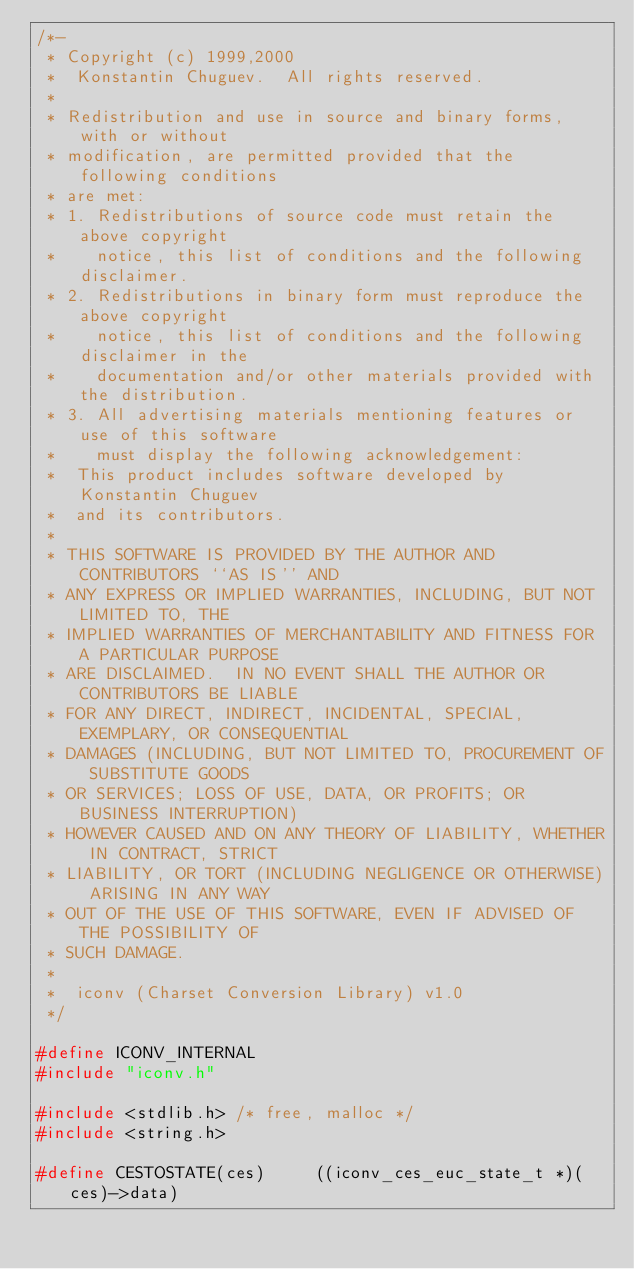<code> <loc_0><loc_0><loc_500><loc_500><_C_>/*-
 * Copyright (c) 1999,2000
 *	Konstantin Chuguev.  All rights reserved.
 *
 * Redistribution and use in source and binary forms, with or without
 * modification, are permitted provided that the following conditions
 * are met:
 * 1. Redistributions of source code must retain the above copyright
 *    notice, this list of conditions and the following disclaimer.
 * 2. Redistributions in binary form must reproduce the above copyright
 *    notice, this list of conditions and the following disclaimer in the
 *    documentation and/or other materials provided with the distribution.
 * 3. All advertising materials mentioning features or use of this software
 *    must display the following acknowledgement:
 *	This product includes software developed by Konstantin Chuguev
 *	and its contributors.
 *
 * THIS SOFTWARE IS PROVIDED BY THE AUTHOR AND CONTRIBUTORS ``AS IS'' AND
 * ANY EXPRESS OR IMPLIED WARRANTIES, INCLUDING, BUT NOT LIMITED TO, THE
 * IMPLIED WARRANTIES OF MERCHANTABILITY AND FITNESS FOR A PARTICULAR PURPOSE
 * ARE DISCLAIMED.  IN NO EVENT SHALL THE AUTHOR OR CONTRIBUTORS BE LIABLE
 * FOR ANY DIRECT, INDIRECT, INCIDENTAL, SPECIAL, EXEMPLARY, OR CONSEQUENTIAL
 * DAMAGES (INCLUDING, BUT NOT LIMITED TO, PROCUREMENT OF SUBSTITUTE GOODS
 * OR SERVICES; LOSS OF USE, DATA, OR PROFITS; OR BUSINESS INTERRUPTION)
 * HOWEVER CAUSED AND ON ANY THEORY OF LIABILITY, WHETHER IN CONTRACT, STRICT
 * LIABILITY, OR TORT (INCLUDING NEGLIGENCE OR OTHERWISE) ARISING IN ANY WAY
 * OUT OF THE USE OF THIS SOFTWARE, EVEN IF ADVISED OF THE POSSIBILITY OF
 * SUCH DAMAGE.
 *
 *	iconv (Charset Conversion Library) v1.0
 */

#define ICONV_INTERNAL
#include "iconv.h"

#include <stdlib.h>	/* free, malloc */
#include <string.h>

#define	CESTOSTATE(ces)		((iconv_ces_euc_state_t *)(ces)->data)</code> 